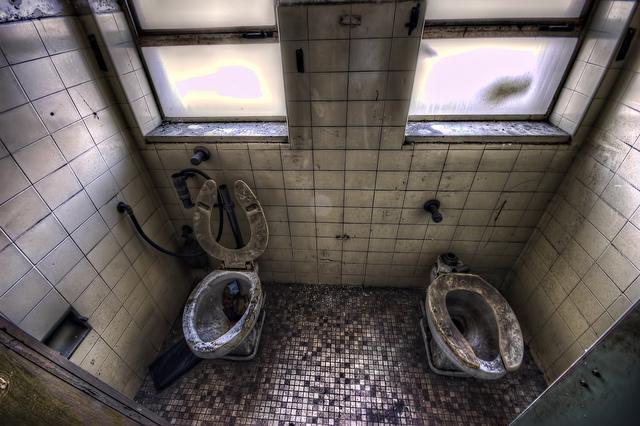How many toilets are seen?
Give a very brief answer. 2. How many toilets are in the photo?
Give a very brief answer. 2. 